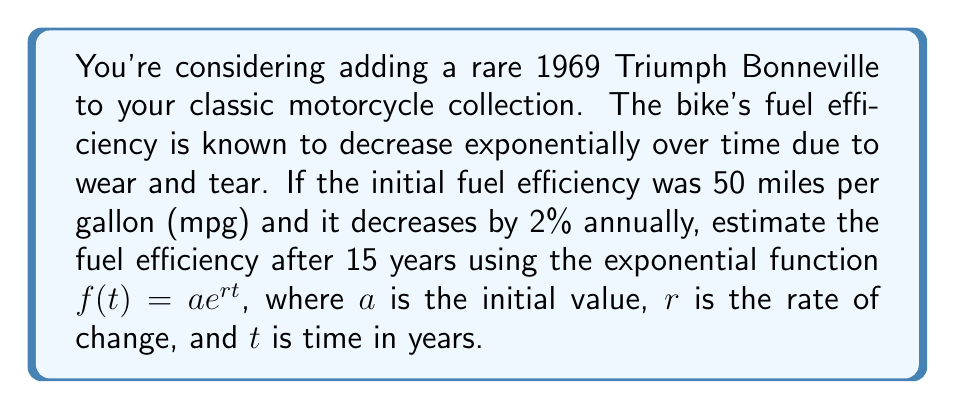Can you solve this math problem? To solve this problem, we'll use the exponential function $f(t) = ae^{rt}$, where:

$a = 50$ (initial fuel efficiency in mpg)
$r = -0.02$ (2% annual decrease, expressed as a decimal and negative since it's decreasing)
$t = 15$ (years)

Step 1: Substitute the values into the exponential function.
$f(15) = 50e^{(-0.02)(15)}$

Step 2: Simplify the exponent.
$f(15) = 50e^{-0.3}$

Step 3: Calculate the value of $e^{-0.3}$ using a calculator.
$e^{-0.3} \approx 0.7408$

Step 4: Multiply the result by the initial value.
$f(15) = 50 \times 0.7408 \approx 37.04$

Therefore, after 15 years, the estimated fuel efficiency of the 1969 Triumph Bonneville would be approximately 37.04 mpg.
Answer: 37.04 mpg 